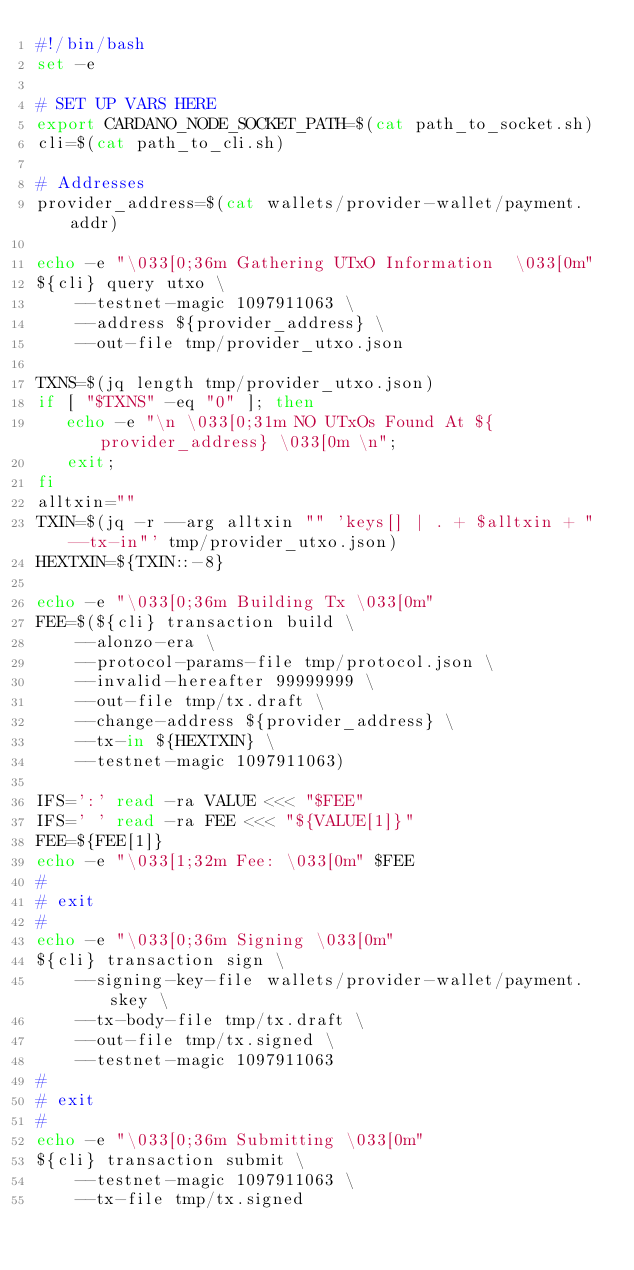Convert code to text. <code><loc_0><loc_0><loc_500><loc_500><_Bash_>#!/bin/bash
set -e

# SET UP VARS HERE
export CARDANO_NODE_SOCKET_PATH=$(cat path_to_socket.sh)
cli=$(cat path_to_cli.sh)

# Addresses
provider_address=$(cat wallets/provider-wallet/payment.addr)

echo -e "\033[0;36m Gathering UTxO Information  \033[0m"
${cli} query utxo \
    --testnet-magic 1097911063 \
    --address ${provider_address} \
    --out-file tmp/provider_utxo.json

TXNS=$(jq length tmp/provider_utxo.json)
if [ "$TXNS" -eq "0" ]; then
   echo -e "\n \033[0;31m NO UTxOs Found At ${provider_address} \033[0m \n";
   exit;
fi
alltxin=""
TXIN=$(jq -r --arg alltxin "" 'keys[] | . + $alltxin + " --tx-in"' tmp/provider_utxo.json)
HEXTXIN=${TXIN::-8}

echo -e "\033[0;36m Building Tx \033[0m"
FEE=$(${cli} transaction build \
    --alonzo-era \
    --protocol-params-file tmp/protocol.json \
    --invalid-hereafter 99999999 \
    --out-file tmp/tx.draft \
    --change-address ${provider_address} \
    --tx-in ${HEXTXIN} \
    --testnet-magic 1097911063)

IFS=':' read -ra VALUE <<< "$FEE"
IFS=' ' read -ra FEE <<< "${VALUE[1]}"
FEE=${FEE[1]}
echo -e "\033[1;32m Fee: \033[0m" $FEE
#
# exit
#
echo -e "\033[0;36m Signing \033[0m"
${cli} transaction sign \
    --signing-key-file wallets/provider-wallet/payment.skey \
    --tx-body-file tmp/tx.draft \
    --out-file tmp/tx.signed \
    --testnet-magic 1097911063
#
# exit
#
echo -e "\033[0;36m Submitting \033[0m"
${cli} transaction submit \
    --testnet-magic 1097911063 \
    --tx-file tmp/tx.signed</code> 